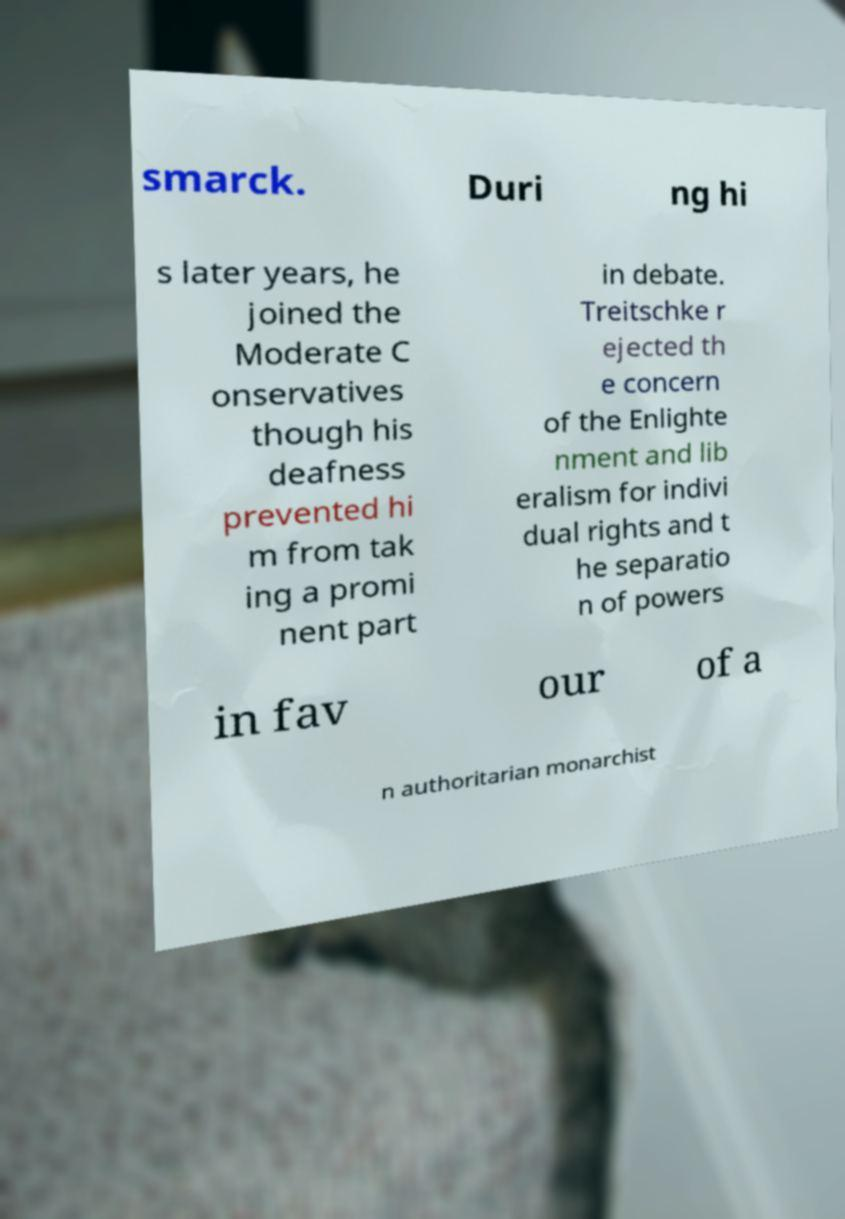Could you extract and type out the text from this image? smarck. Duri ng hi s later years, he joined the Moderate C onservatives though his deafness prevented hi m from tak ing a promi nent part in debate. Treitschke r ejected th e concern of the Enlighte nment and lib eralism for indivi dual rights and t he separatio n of powers in fav our of a n authoritarian monarchist 